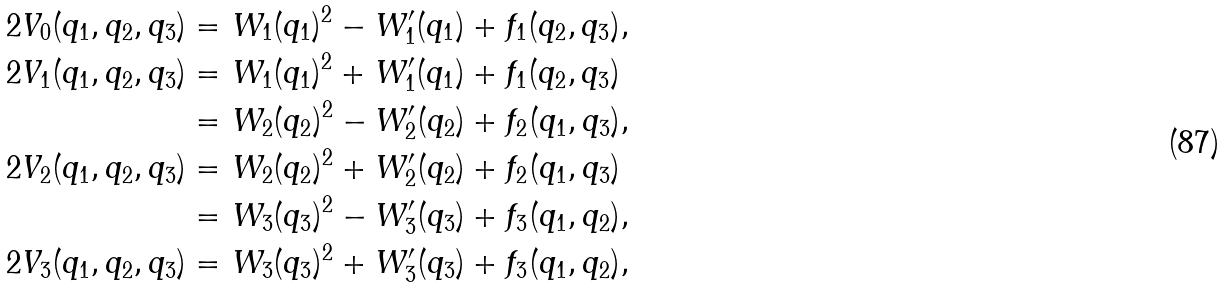Convert formula to latex. <formula><loc_0><loc_0><loc_500><loc_500>2 V _ { 0 } ( q _ { 1 } , q _ { 2 } , q _ { 3 } ) & = W _ { 1 } ( q _ { 1 } ) ^ { 2 } - W ^ { \prime } _ { 1 } ( q _ { 1 } ) + f _ { 1 } ( q _ { 2 } , q _ { 3 } ) , \\ 2 V _ { 1 } ( q _ { 1 } , q _ { 2 } , q _ { 3 } ) & = W _ { 1 } ( q _ { 1 } ) ^ { 2 } + W ^ { \prime } _ { 1 } ( q _ { 1 } ) + f _ { 1 } ( q _ { 2 } , q _ { 3 } ) \\ & = W _ { 2 } ( q _ { 2 } ) ^ { 2 } - W ^ { \prime } _ { 2 } ( q _ { 2 } ) + f _ { 2 } ( q _ { 1 } , q _ { 3 } ) , \\ 2 V _ { 2 } ( q _ { 1 } , q _ { 2 } , q _ { 3 } ) & = W _ { 2 } ( q _ { 2 } ) ^ { 2 } + W ^ { \prime } _ { 2 } ( q _ { 2 } ) + f _ { 2 } ( q _ { 1 } , q _ { 3 } ) \\ & = W _ { 3 } ( q _ { 3 } ) ^ { 2 } - W ^ { \prime } _ { 3 } ( q _ { 3 } ) + f _ { 3 } ( q _ { 1 } , q _ { 2 } ) , \\ 2 V _ { 3 } ( q _ { 1 } , q _ { 2 } , q _ { 3 } ) & = W _ { 3 } ( q _ { 3 } ) ^ { 2 } + W ^ { \prime } _ { 3 } ( q _ { 3 } ) + f _ { 3 } ( q _ { 1 } , q _ { 2 } ) ,</formula> 